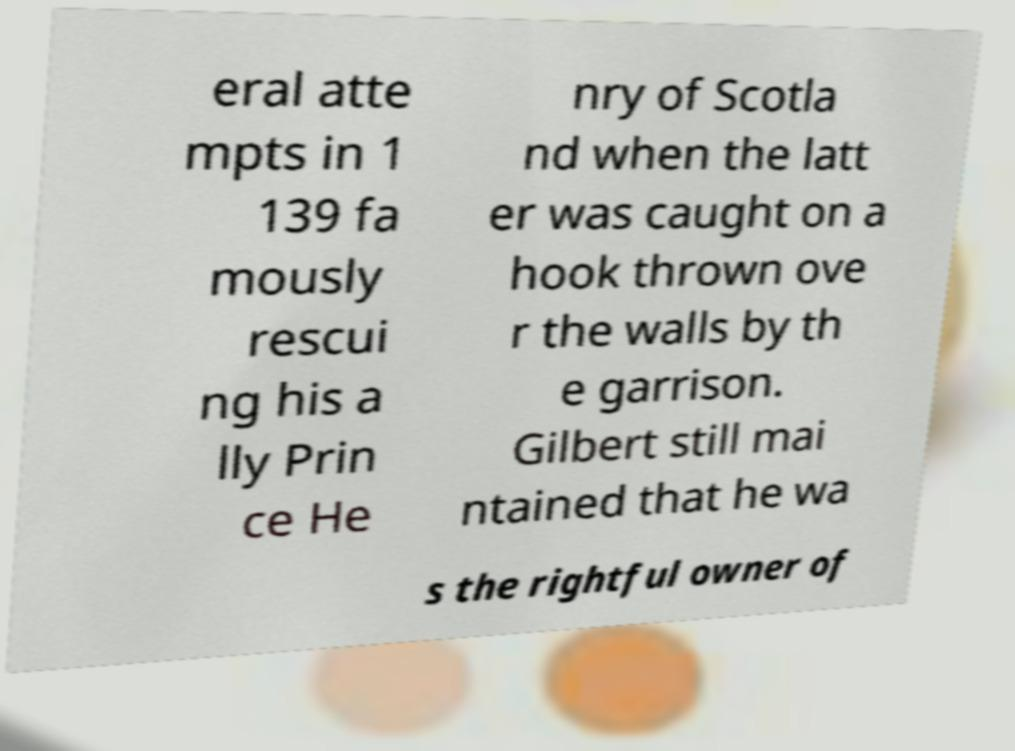Can you accurately transcribe the text from the provided image for me? eral atte mpts in 1 139 fa mously rescui ng his a lly Prin ce He nry of Scotla nd when the latt er was caught on a hook thrown ove r the walls by th e garrison. Gilbert still mai ntained that he wa s the rightful owner of 